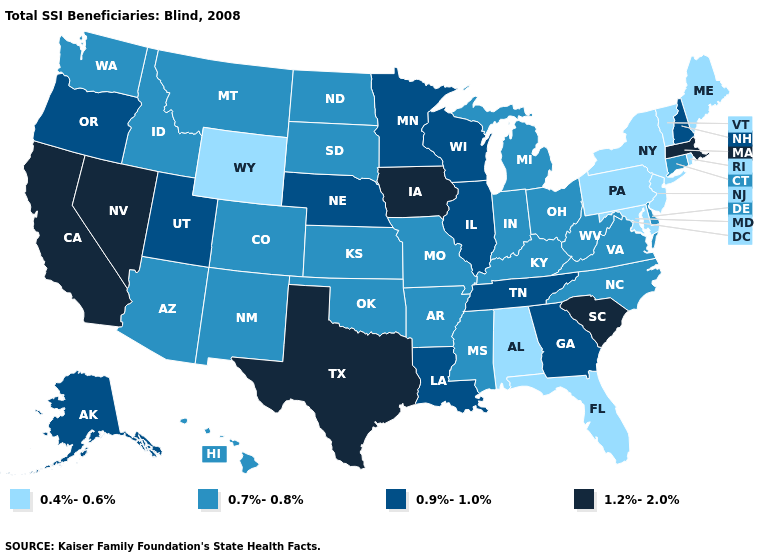What is the highest value in the West ?
Short answer required. 1.2%-2.0%. Does the first symbol in the legend represent the smallest category?
Concise answer only. Yes. Does the map have missing data?
Give a very brief answer. No. Does Indiana have a lower value than Nevada?
Write a very short answer. Yes. Among the states that border South Dakota , which have the highest value?
Keep it brief. Iowa. What is the value of Idaho?
Answer briefly. 0.7%-0.8%. Does West Virginia have the same value as South Carolina?
Keep it brief. No. What is the highest value in the South ?
Answer briefly. 1.2%-2.0%. What is the highest value in the Northeast ?
Write a very short answer. 1.2%-2.0%. What is the value of Pennsylvania?
Concise answer only. 0.4%-0.6%. Does the first symbol in the legend represent the smallest category?
Write a very short answer. Yes. What is the highest value in the Northeast ?
Give a very brief answer. 1.2%-2.0%. What is the value of Tennessee?
Concise answer only. 0.9%-1.0%. What is the highest value in the USA?
Keep it brief. 1.2%-2.0%. What is the value of California?
Short answer required. 1.2%-2.0%. 